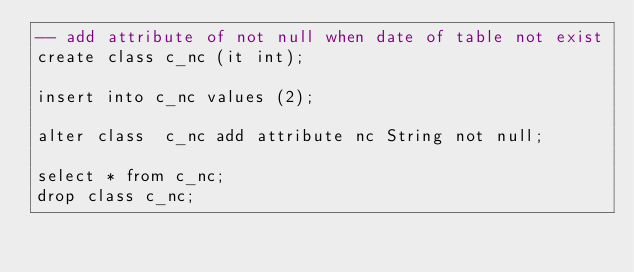<code> <loc_0><loc_0><loc_500><loc_500><_SQL_>-- add attribute of not null when date of table not exist
create class c_nc (it int);

insert into c_nc values (2);

alter class  c_nc add attribute nc String not null;

select * from c_nc;
drop class c_nc;</code> 